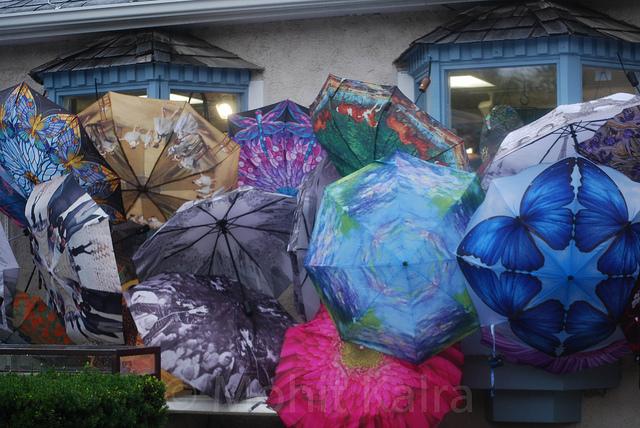Are the umbrellas colorful?
Quick response, please. Yes. If one of these is your umbrella would it be easy to find?
Keep it brief. Yes. How many blue umbrellas are there?
Concise answer only. 3. 